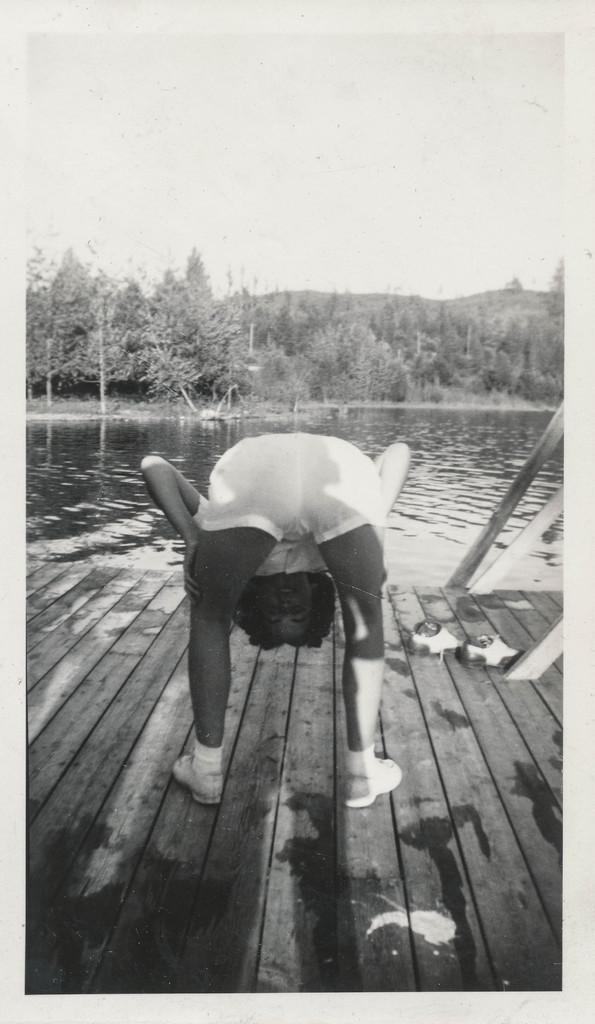What is present in the image? There is a person in the image. What natural element is visible in the image? There is water visible in the image. What can be seen in the background of the image? There are trees and the sky visible in the background of the image. What advice does the person's aunt give them in the image? There is no mention of an aunt or any advice in the image. What innovative idea does the person have in the image? There is no indication of any innovative idea in the image. 